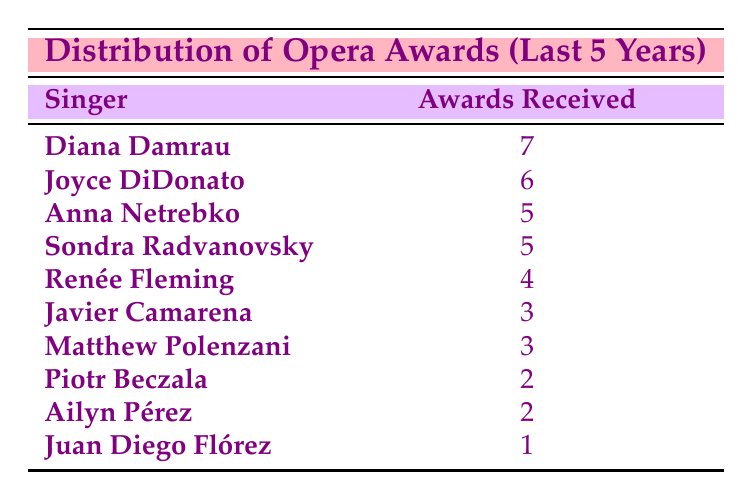What is the highest number of awards received by a singer? The table shows that the highest number of awards received is 7, attributed to Diana Damrau.
Answer: 7 Which singers received the same number of awards, and how many? Anna Netrebko and Sondra Radvanovsky both received 5 awards, as indicated in their respective rows.
Answer: Anna Netrebko and Sondra Radvanovsky, 5 awards Are there any singers who received only 1 award? The table lists Juan Diego Flórez with 1 award, confirming there is at least one singer who received only 1 award.
Answer: Yes What is the total number of awards received by all singers? By adding the awards: 7 + 6 + 5 + 5 + 4 + 3 + 3 + 2 + 2 + 1 = 38, the total number of awards received is 38.
Answer: 38 How many singers received more than 4 awards? The singers who received more than 4 awards are Diana Damrau, Joyce DiDonato, Anna Netrebko, and Sondra Radvanovsky, totaling 4 singers.
Answer: 4 What is the average number of awards received by the singers? The sum of awards is 38 for 10 singers. Dividing 38 by 10 gives an average of 3.8 awards per singer.
Answer: 3.8 Did Renée Fleming receive more awards than Ailyn Pérez? Renée Fleming received 4 awards and Ailyn Pérez received 2 awards, confirming that Renée Fleming received more awards.
Answer: Yes Which singer received the fewest awards, and how many? The table indicates that Juan Diego Flórez received the fewest awards, which is 1.
Answer: Juan Diego Flórez, 1 award How many singers received exactly 3 awards? The table shows that both Javier Camarena and Matthew Polenzani received 3 awards, totaling 2 singers.
Answer: 2 